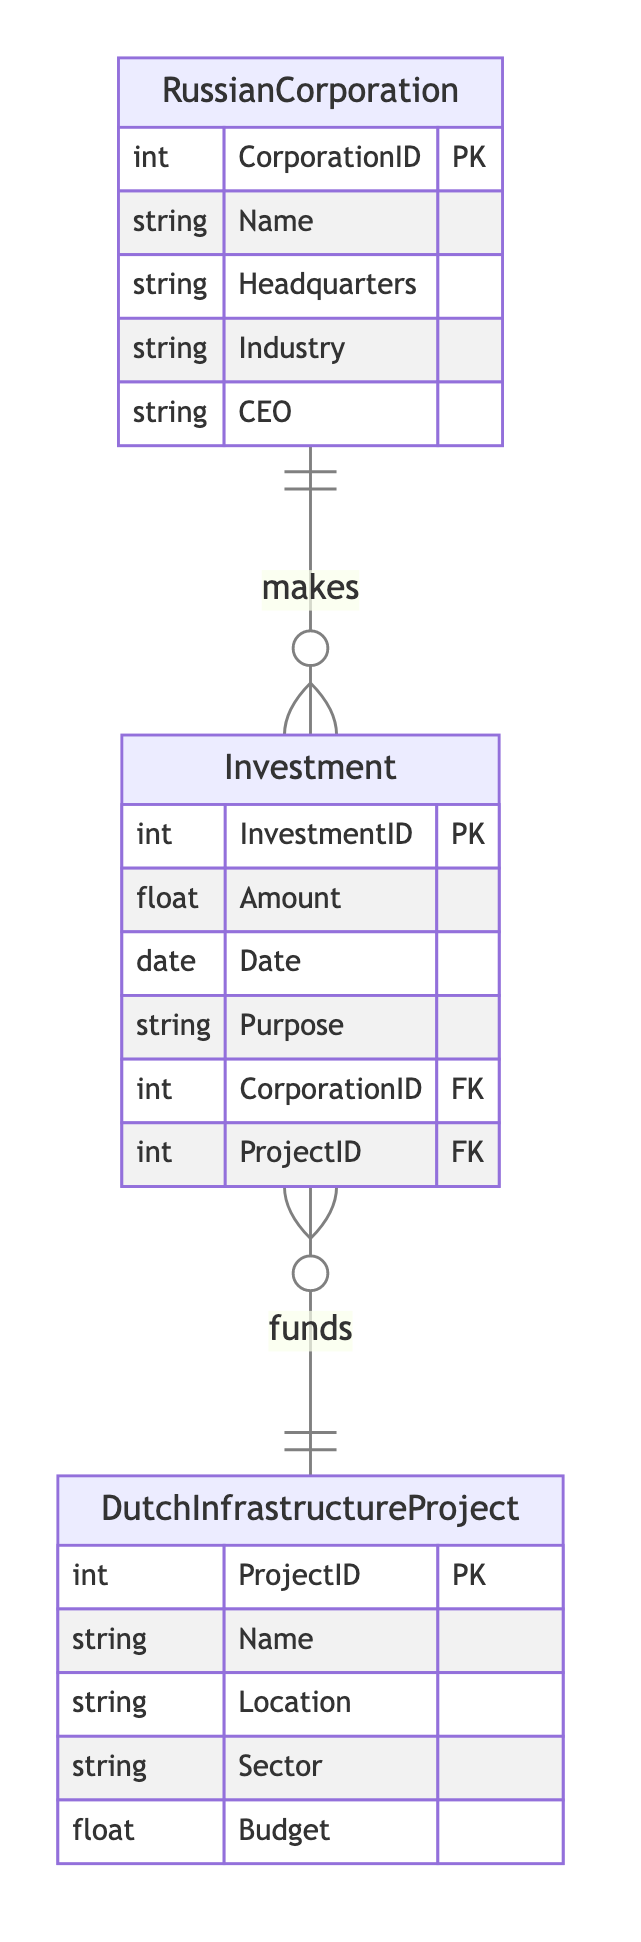What entities are present in the diagram? The diagram contains three entities: RussianCorporation, DutchInfrastructureProject, and Investment. The names of the entities can be found in the Entities section of the provided data.
Answer: RussianCorporation, DutchInfrastructureProject, Investment How many attributes are there for DutchInfrastructureProject? The DutchInfrastructureProject entity has five attributes listed: ProjectID, Name, Location, Sector, and Budget. The count is determined by reviewing the Attributes section for that specific entity.
Answer: 5 What is the primary key for the Investment entity? The primary key for the Investment entity is InvestmentID, which is stated in the Attributes section of the Investment entity within the diagram description.
Answer: InvestmentID What relationship exists between RussianCorporation and DutchInfrastructureProject? The relationship type is "InvestsIn," which indicates that RussianCorporation makes investments in DutchInfrastructureProject. This is directly stated in the Relationships section of the provided data.
Answer: InvestsIn Which attribute links Investment to RussianCorporation? The attribute that links Investment to RussianCorporation is CorporationID, which is defined as a foreign key in the Investment entity. This can be seen in the relationship attributes that connect these two entities.
Answer: CorporationID How many foreign keys are in the Investment entity? The Investment entity has two foreign keys: CorporationID and ProjectID. This is found by counting the foreign key attributes listed under the Investment entity in the diagram's code.
Answer: 2 What is the purpose of the Investment entity? The purpose attribute in the Investment entity indicates the reason for making that particular investment in Dutch infrastructure. This attribute is directly mentioned under the Investment entity description.
Answer: Purpose What does the industry of a RussianCorporation describe? The industry attribute describes the sector in which a Russian corporation operates, such as technology, energy, or manufacturing. This attribute is explicitly defined in the RussianCorporation entity section.
Answer: Sector What types of projects can be funded as DutchInfrastructureProjects? The DutchInfrastructureProject can be in various sectors, which is outlined by the Sector attribute. This attribute suggests that the projects can belong to multiple types such as transportation, energy, or healthcare.
Answer: Various sectors 